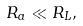Convert formula to latex. <formula><loc_0><loc_0><loc_500><loc_500>R _ { a } \ll R _ { L } ,</formula> 